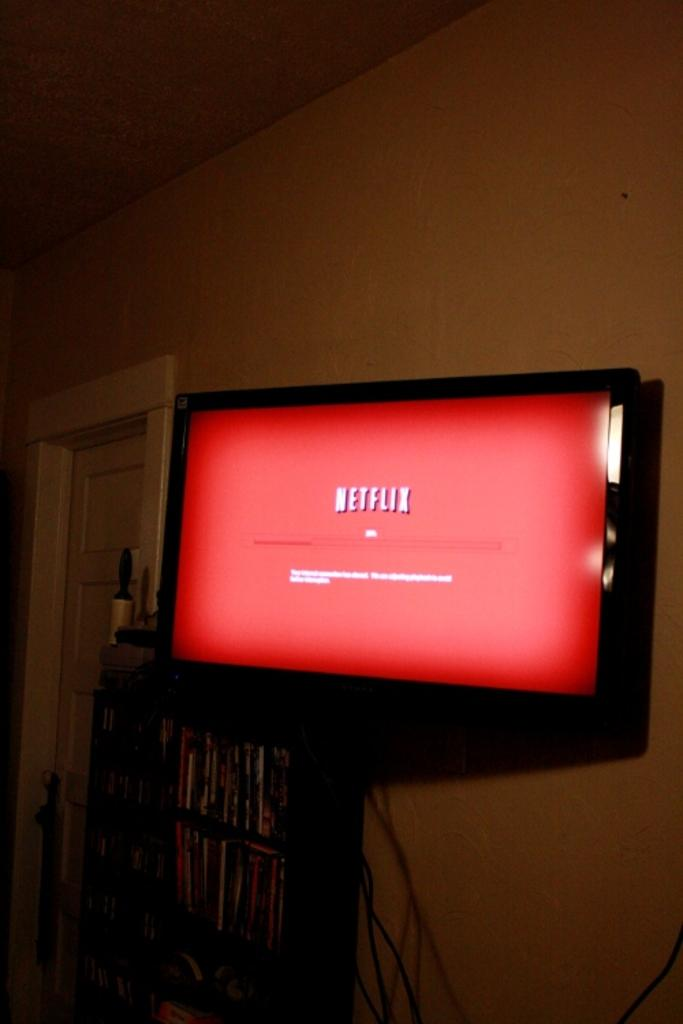<image>
Render a clear and concise summary of the photo. A TV hanging on the wall that is showing a Netflix sign. 